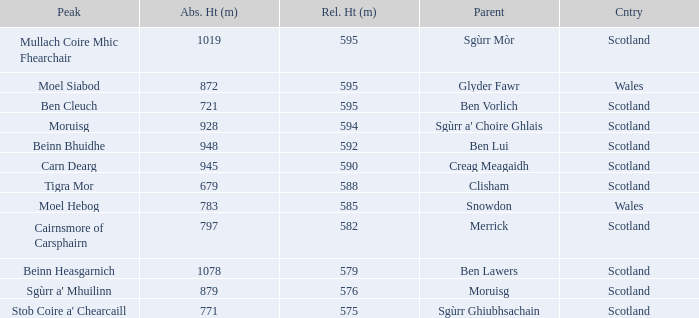What is the relative height of Scotland with Ben Vorlich as parent? 1.0. 